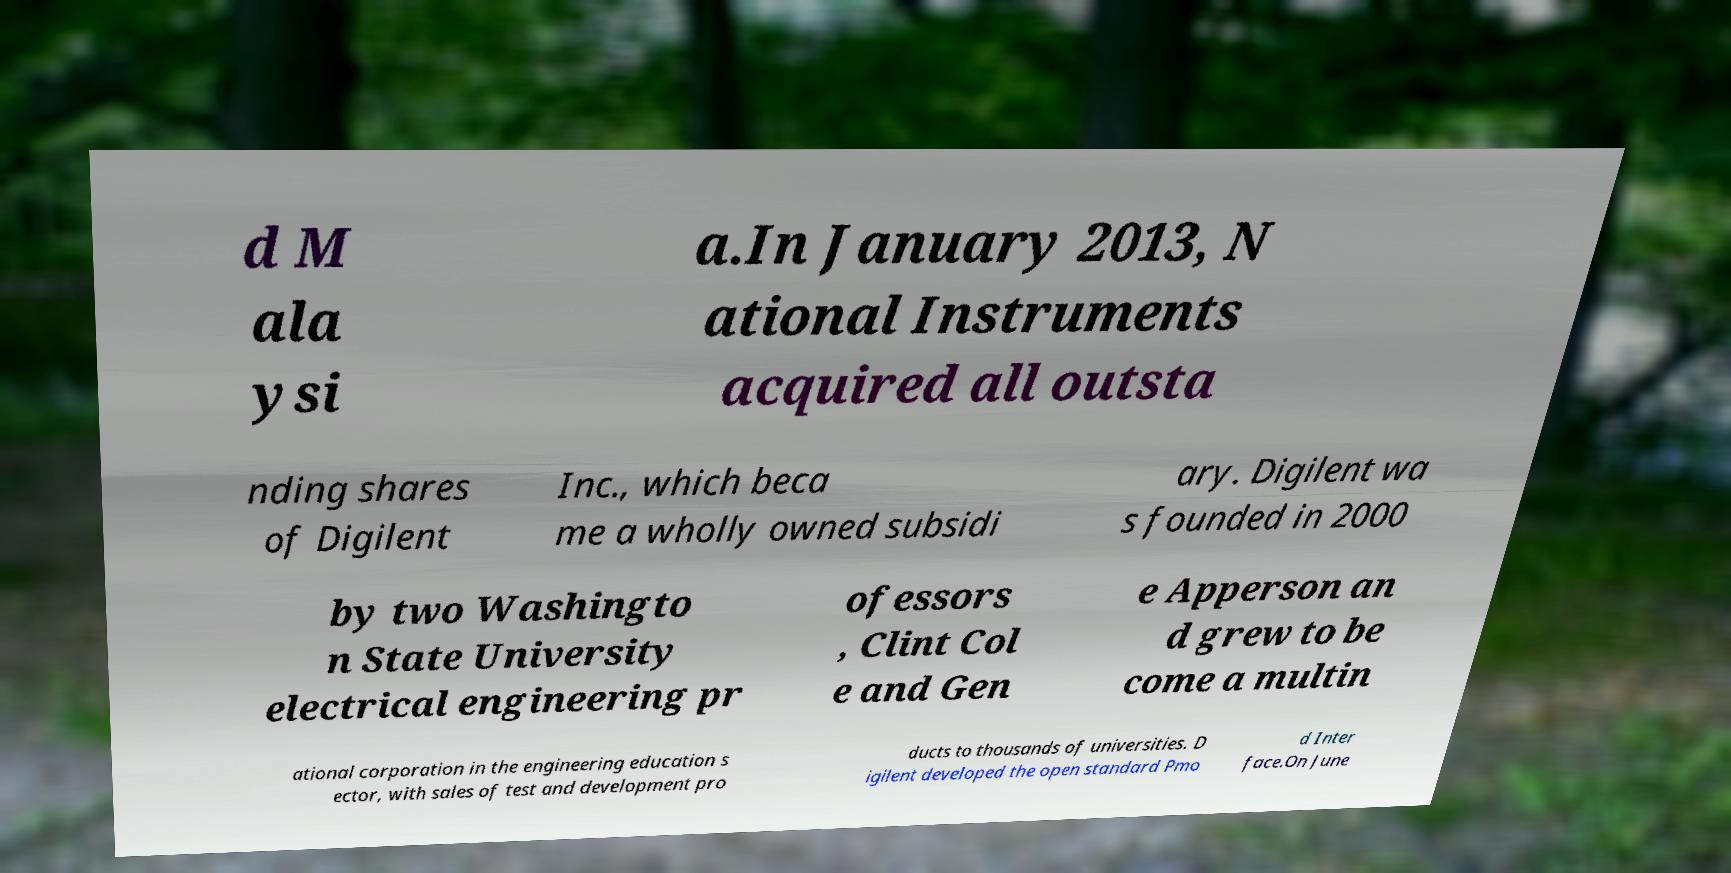Please identify and transcribe the text found in this image. d M ala ysi a.In January 2013, N ational Instruments acquired all outsta nding shares of Digilent Inc., which beca me a wholly owned subsidi ary. Digilent wa s founded in 2000 by two Washingto n State University electrical engineering pr ofessors , Clint Col e and Gen e Apperson an d grew to be come a multin ational corporation in the engineering education s ector, with sales of test and development pro ducts to thousands of universities. D igilent developed the open standard Pmo d Inter face.On June 